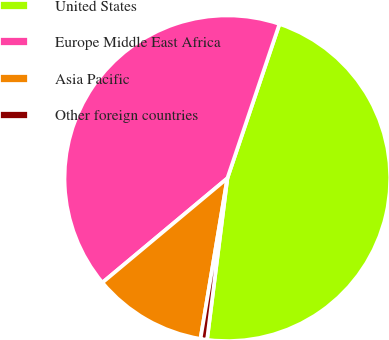Convert chart. <chart><loc_0><loc_0><loc_500><loc_500><pie_chart><fcel>United States<fcel>Europe Middle East Africa<fcel>Asia Pacific<fcel>Other foreign countries<nl><fcel>46.81%<fcel>41.26%<fcel>11.29%<fcel>0.65%<nl></chart> 